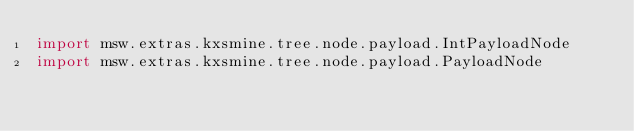Convert code to text. <code><loc_0><loc_0><loc_500><loc_500><_Kotlin_>import msw.extras.kxsmine.tree.node.payload.IntPayloadNode
import msw.extras.kxsmine.tree.node.payload.PayloadNode
</code> 